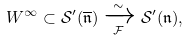Convert formula to latex. <formula><loc_0><loc_0><loc_500><loc_500>W ^ { \infty } \subset \mathcal { S } ^ { \prime } ( \overline { \mathfrak { n } } ) \xrightarrow [ \mathcal { F } ] { \sim } \mathcal { S } ^ { \prime } ( \mathfrak { n } ) ,</formula> 